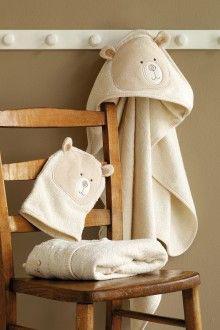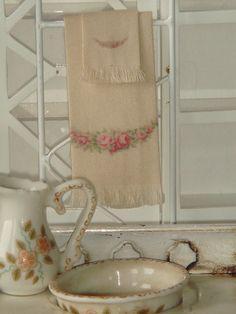The first image is the image on the left, the second image is the image on the right. Given the left and right images, does the statement "A porcelain pitcher is shown by something made of fabric in one image." hold true? Answer yes or no. Yes. The first image is the image on the left, the second image is the image on the right. Analyze the images presented: Is the assertion "The outside can be seen in the image on the left." valid? Answer yes or no. No. 